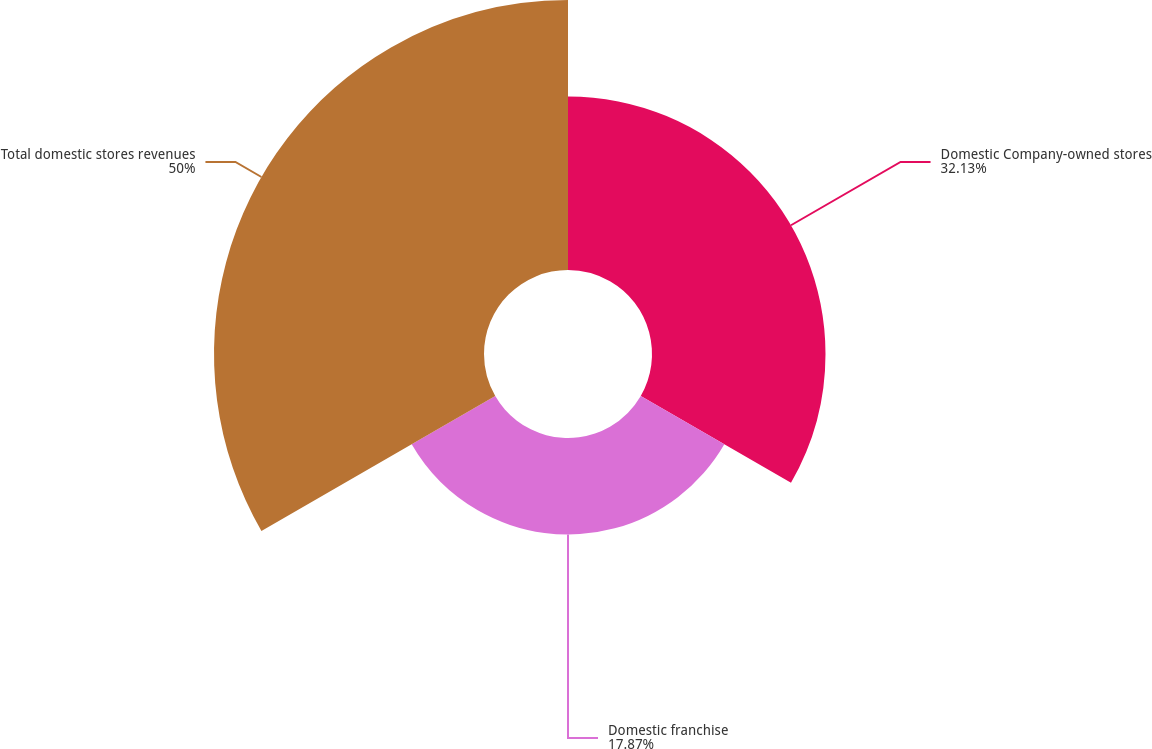<chart> <loc_0><loc_0><loc_500><loc_500><pie_chart><fcel>Domestic Company-owned stores<fcel>Domestic franchise<fcel>Total domestic stores revenues<nl><fcel>32.13%<fcel>17.87%<fcel>50.0%<nl></chart> 